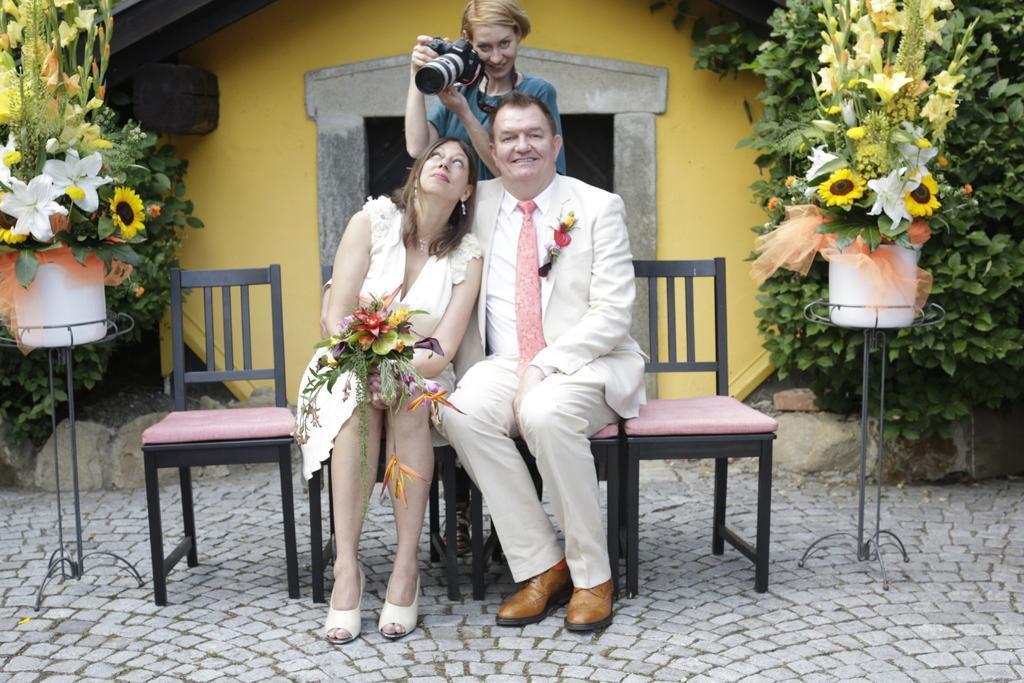How would you summarize this image in a sentence or two? The image is outside a building. in this image one man and woman sitting on chair. They are wearing white dress. The woman is holding bouquet. There are two more chairs beside them. behind them a lady is holding a camera. On the both side of them there are flower vase. In the right top corner there is tree. In the background there is building. All are looking happy. The floor is made up of cobblestones. 